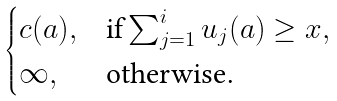Convert formula to latex. <formula><loc_0><loc_0><loc_500><loc_500>\begin{cases} c ( a ) , & \text {if} \sum _ { j = 1 } ^ { i } u _ { j } ( a ) \geq x , \\ \infty , & \text {otherwise.} \end{cases}</formula> 